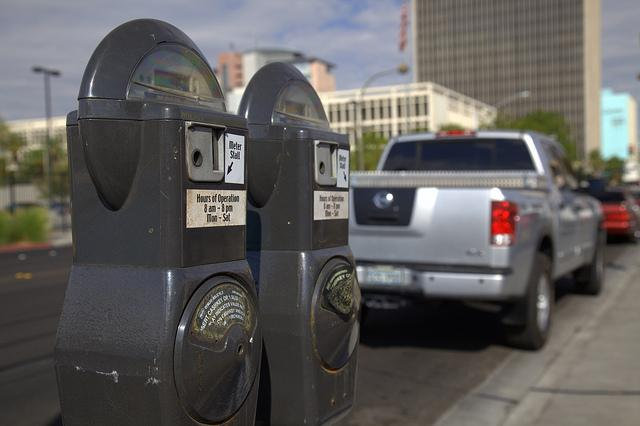What is the purpose of the object? Please explain your reasoning. provide parking. The parking meter needs to be fed for cars to park. 